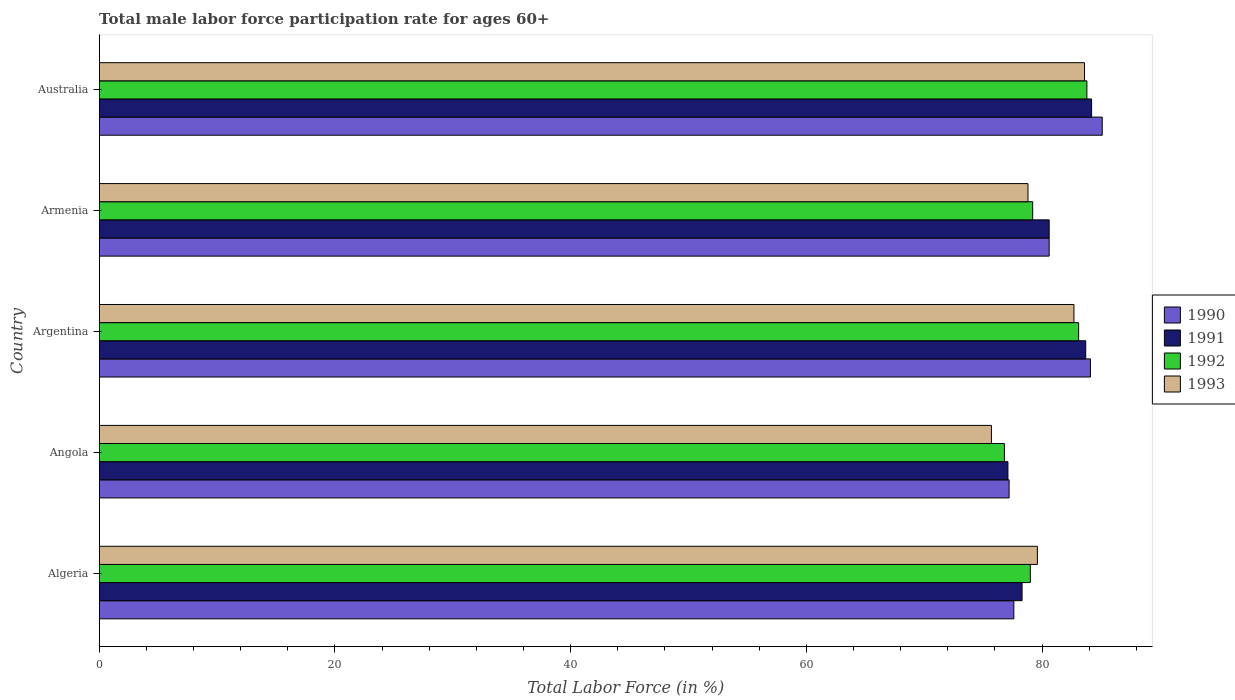How many different coloured bars are there?
Provide a short and direct response. 4. How many bars are there on the 2nd tick from the top?
Offer a terse response. 4. How many bars are there on the 4th tick from the bottom?
Keep it short and to the point. 4. What is the label of the 5th group of bars from the top?
Your answer should be very brief. Algeria. What is the male labor force participation rate in 1991 in Argentina?
Provide a short and direct response. 83.7. Across all countries, what is the maximum male labor force participation rate in 1991?
Keep it short and to the point. 84.2. Across all countries, what is the minimum male labor force participation rate in 1992?
Give a very brief answer. 76.8. In which country was the male labor force participation rate in 1991 maximum?
Provide a short and direct response. Australia. In which country was the male labor force participation rate in 1990 minimum?
Your answer should be compact. Angola. What is the total male labor force participation rate in 1992 in the graph?
Keep it short and to the point. 401.9. What is the difference between the male labor force participation rate in 1993 in Algeria and that in Armenia?
Offer a very short reply. 0.8. What is the average male labor force participation rate in 1990 per country?
Make the answer very short. 80.92. What is the difference between the male labor force participation rate in 1990 and male labor force participation rate in 1991 in Australia?
Offer a terse response. 0.9. In how many countries, is the male labor force participation rate in 1991 greater than 40 %?
Make the answer very short. 5. What is the ratio of the male labor force participation rate in 1990 in Algeria to that in Armenia?
Make the answer very short. 0.96. What is the difference between the highest and the second highest male labor force participation rate in 1992?
Your response must be concise. 0.7. What is the difference between the highest and the lowest male labor force participation rate in 1990?
Keep it short and to the point. 7.9. Is the sum of the male labor force participation rate in 1993 in Algeria and Australia greater than the maximum male labor force participation rate in 1991 across all countries?
Your answer should be compact. Yes. What does the 2nd bar from the top in Algeria represents?
Offer a terse response. 1992. What does the 2nd bar from the bottom in Australia represents?
Your answer should be compact. 1991. Is it the case that in every country, the sum of the male labor force participation rate in 1990 and male labor force participation rate in 1991 is greater than the male labor force participation rate in 1993?
Ensure brevity in your answer.  Yes. How many bars are there?
Your answer should be very brief. 20. Are all the bars in the graph horizontal?
Keep it short and to the point. Yes. How many countries are there in the graph?
Provide a short and direct response. 5. Are the values on the major ticks of X-axis written in scientific E-notation?
Provide a succinct answer. No. Does the graph contain any zero values?
Your answer should be compact. No. Where does the legend appear in the graph?
Your answer should be compact. Center right. How many legend labels are there?
Offer a very short reply. 4. How are the legend labels stacked?
Give a very brief answer. Vertical. What is the title of the graph?
Give a very brief answer. Total male labor force participation rate for ages 60+. Does "1978" appear as one of the legend labels in the graph?
Give a very brief answer. No. What is the label or title of the X-axis?
Offer a terse response. Total Labor Force (in %). What is the Total Labor Force (in %) in 1990 in Algeria?
Make the answer very short. 77.6. What is the Total Labor Force (in %) of 1991 in Algeria?
Ensure brevity in your answer.  78.3. What is the Total Labor Force (in %) in 1992 in Algeria?
Offer a terse response. 79. What is the Total Labor Force (in %) in 1993 in Algeria?
Offer a very short reply. 79.6. What is the Total Labor Force (in %) in 1990 in Angola?
Offer a very short reply. 77.2. What is the Total Labor Force (in %) of 1991 in Angola?
Provide a succinct answer. 77.1. What is the Total Labor Force (in %) in 1992 in Angola?
Ensure brevity in your answer.  76.8. What is the Total Labor Force (in %) in 1993 in Angola?
Your response must be concise. 75.7. What is the Total Labor Force (in %) in 1990 in Argentina?
Provide a succinct answer. 84.1. What is the Total Labor Force (in %) in 1991 in Argentina?
Your answer should be very brief. 83.7. What is the Total Labor Force (in %) of 1992 in Argentina?
Provide a succinct answer. 83.1. What is the Total Labor Force (in %) of 1993 in Argentina?
Offer a terse response. 82.7. What is the Total Labor Force (in %) of 1990 in Armenia?
Your answer should be very brief. 80.6. What is the Total Labor Force (in %) of 1991 in Armenia?
Offer a very short reply. 80.6. What is the Total Labor Force (in %) of 1992 in Armenia?
Your answer should be compact. 79.2. What is the Total Labor Force (in %) of 1993 in Armenia?
Ensure brevity in your answer.  78.8. What is the Total Labor Force (in %) of 1990 in Australia?
Ensure brevity in your answer.  85.1. What is the Total Labor Force (in %) in 1991 in Australia?
Offer a very short reply. 84.2. What is the Total Labor Force (in %) of 1992 in Australia?
Keep it short and to the point. 83.8. What is the Total Labor Force (in %) in 1993 in Australia?
Your answer should be very brief. 83.6. Across all countries, what is the maximum Total Labor Force (in %) of 1990?
Offer a terse response. 85.1. Across all countries, what is the maximum Total Labor Force (in %) of 1991?
Provide a short and direct response. 84.2. Across all countries, what is the maximum Total Labor Force (in %) in 1992?
Your response must be concise. 83.8. Across all countries, what is the maximum Total Labor Force (in %) of 1993?
Ensure brevity in your answer.  83.6. Across all countries, what is the minimum Total Labor Force (in %) in 1990?
Your answer should be compact. 77.2. Across all countries, what is the minimum Total Labor Force (in %) in 1991?
Provide a short and direct response. 77.1. Across all countries, what is the minimum Total Labor Force (in %) in 1992?
Offer a terse response. 76.8. Across all countries, what is the minimum Total Labor Force (in %) in 1993?
Ensure brevity in your answer.  75.7. What is the total Total Labor Force (in %) in 1990 in the graph?
Provide a succinct answer. 404.6. What is the total Total Labor Force (in %) of 1991 in the graph?
Provide a short and direct response. 403.9. What is the total Total Labor Force (in %) of 1992 in the graph?
Provide a succinct answer. 401.9. What is the total Total Labor Force (in %) of 1993 in the graph?
Your response must be concise. 400.4. What is the difference between the Total Labor Force (in %) of 1990 in Algeria and that in Angola?
Offer a terse response. 0.4. What is the difference between the Total Labor Force (in %) in 1993 in Algeria and that in Angola?
Provide a short and direct response. 3.9. What is the difference between the Total Labor Force (in %) of 1991 in Algeria and that in Argentina?
Your answer should be compact. -5.4. What is the difference between the Total Labor Force (in %) in 1993 in Algeria and that in Argentina?
Your answer should be very brief. -3.1. What is the difference between the Total Labor Force (in %) in 1990 in Algeria and that in Armenia?
Your answer should be very brief. -3. What is the difference between the Total Labor Force (in %) in 1991 in Algeria and that in Armenia?
Ensure brevity in your answer.  -2.3. What is the difference between the Total Labor Force (in %) in 1992 in Algeria and that in Armenia?
Keep it short and to the point. -0.2. What is the difference between the Total Labor Force (in %) in 1993 in Algeria and that in Armenia?
Provide a succinct answer. 0.8. What is the difference between the Total Labor Force (in %) in 1990 in Algeria and that in Australia?
Ensure brevity in your answer.  -7.5. What is the difference between the Total Labor Force (in %) of 1993 in Algeria and that in Australia?
Keep it short and to the point. -4. What is the difference between the Total Labor Force (in %) in 1991 in Angola and that in Argentina?
Make the answer very short. -6.6. What is the difference between the Total Labor Force (in %) of 1992 in Angola and that in Argentina?
Make the answer very short. -6.3. What is the difference between the Total Labor Force (in %) in 1990 in Angola and that in Armenia?
Ensure brevity in your answer.  -3.4. What is the difference between the Total Labor Force (in %) in 1991 in Angola and that in Armenia?
Your answer should be compact. -3.5. What is the difference between the Total Labor Force (in %) in 1992 in Angola and that in Armenia?
Keep it short and to the point. -2.4. What is the difference between the Total Labor Force (in %) in 1992 in Angola and that in Australia?
Offer a very short reply. -7. What is the difference between the Total Labor Force (in %) in 1992 in Argentina and that in Armenia?
Provide a succinct answer. 3.9. What is the difference between the Total Labor Force (in %) in 1993 in Argentina and that in Armenia?
Your response must be concise. 3.9. What is the difference between the Total Labor Force (in %) of 1993 in Argentina and that in Australia?
Give a very brief answer. -0.9. What is the difference between the Total Labor Force (in %) in 1990 in Algeria and the Total Labor Force (in %) in 1993 in Angola?
Keep it short and to the point. 1.9. What is the difference between the Total Labor Force (in %) of 1991 in Algeria and the Total Labor Force (in %) of 1992 in Angola?
Offer a terse response. 1.5. What is the difference between the Total Labor Force (in %) in 1990 in Algeria and the Total Labor Force (in %) in 1991 in Argentina?
Keep it short and to the point. -6.1. What is the difference between the Total Labor Force (in %) of 1990 in Algeria and the Total Labor Force (in %) of 1992 in Argentina?
Your answer should be compact. -5.5. What is the difference between the Total Labor Force (in %) in 1991 in Algeria and the Total Labor Force (in %) in 1992 in Argentina?
Provide a short and direct response. -4.8. What is the difference between the Total Labor Force (in %) in 1990 in Algeria and the Total Labor Force (in %) in 1991 in Armenia?
Give a very brief answer. -3. What is the difference between the Total Labor Force (in %) of 1990 in Algeria and the Total Labor Force (in %) of 1991 in Australia?
Give a very brief answer. -6.6. What is the difference between the Total Labor Force (in %) of 1990 in Algeria and the Total Labor Force (in %) of 1992 in Australia?
Ensure brevity in your answer.  -6.2. What is the difference between the Total Labor Force (in %) of 1991 in Algeria and the Total Labor Force (in %) of 1993 in Australia?
Your answer should be very brief. -5.3. What is the difference between the Total Labor Force (in %) in 1992 in Algeria and the Total Labor Force (in %) in 1993 in Australia?
Provide a succinct answer. -4.6. What is the difference between the Total Labor Force (in %) of 1990 in Angola and the Total Labor Force (in %) of 1991 in Argentina?
Keep it short and to the point. -6.5. What is the difference between the Total Labor Force (in %) of 1990 in Angola and the Total Labor Force (in %) of 1992 in Argentina?
Provide a short and direct response. -5.9. What is the difference between the Total Labor Force (in %) of 1991 in Angola and the Total Labor Force (in %) of 1992 in Argentina?
Ensure brevity in your answer.  -6. What is the difference between the Total Labor Force (in %) of 1992 in Angola and the Total Labor Force (in %) of 1993 in Argentina?
Give a very brief answer. -5.9. What is the difference between the Total Labor Force (in %) in 1990 in Angola and the Total Labor Force (in %) in 1991 in Armenia?
Offer a terse response. -3.4. What is the difference between the Total Labor Force (in %) in 1991 in Angola and the Total Labor Force (in %) in 1992 in Armenia?
Ensure brevity in your answer.  -2.1. What is the difference between the Total Labor Force (in %) of 1991 in Angola and the Total Labor Force (in %) of 1993 in Armenia?
Provide a succinct answer. -1.7. What is the difference between the Total Labor Force (in %) in 1990 in Argentina and the Total Labor Force (in %) in 1993 in Armenia?
Offer a terse response. 5.3. What is the difference between the Total Labor Force (in %) in 1991 in Argentina and the Total Labor Force (in %) in 1992 in Armenia?
Offer a terse response. 4.5. What is the difference between the Total Labor Force (in %) of 1990 in Argentina and the Total Labor Force (in %) of 1992 in Australia?
Offer a very short reply. 0.3. What is the difference between the Total Labor Force (in %) of 1990 in Argentina and the Total Labor Force (in %) of 1993 in Australia?
Provide a succinct answer. 0.5. What is the difference between the Total Labor Force (in %) in 1991 in Argentina and the Total Labor Force (in %) in 1993 in Australia?
Your answer should be very brief. 0.1. What is the difference between the Total Labor Force (in %) of 1992 in Argentina and the Total Labor Force (in %) of 1993 in Australia?
Keep it short and to the point. -0.5. What is the difference between the Total Labor Force (in %) in 1990 in Armenia and the Total Labor Force (in %) in 1991 in Australia?
Make the answer very short. -3.6. What is the difference between the Total Labor Force (in %) in 1990 in Armenia and the Total Labor Force (in %) in 1992 in Australia?
Your response must be concise. -3.2. What is the difference between the Total Labor Force (in %) in 1990 in Armenia and the Total Labor Force (in %) in 1993 in Australia?
Give a very brief answer. -3. What is the difference between the Total Labor Force (in %) of 1992 in Armenia and the Total Labor Force (in %) of 1993 in Australia?
Keep it short and to the point. -4.4. What is the average Total Labor Force (in %) of 1990 per country?
Make the answer very short. 80.92. What is the average Total Labor Force (in %) in 1991 per country?
Offer a very short reply. 80.78. What is the average Total Labor Force (in %) in 1992 per country?
Provide a short and direct response. 80.38. What is the average Total Labor Force (in %) of 1993 per country?
Your response must be concise. 80.08. What is the difference between the Total Labor Force (in %) of 1990 and Total Labor Force (in %) of 1991 in Algeria?
Make the answer very short. -0.7. What is the difference between the Total Labor Force (in %) in 1990 and Total Labor Force (in %) in 1992 in Algeria?
Provide a succinct answer. -1.4. What is the difference between the Total Labor Force (in %) of 1991 and Total Labor Force (in %) of 1992 in Algeria?
Your response must be concise. -0.7. What is the difference between the Total Labor Force (in %) of 1991 and Total Labor Force (in %) of 1993 in Algeria?
Your answer should be compact. -1.3. What is the difference between the Total Labor Force (in %) in 1992 and Total Labor Force (in %) in 1993 in Algeria?
Give a very brief answer. -0.6. What is the difference between the Total Labor Force (in %) of 1990 and Total Labor Force (in %) of 1992 in Angola?
Your response must be concise. 0.4. What is the difference between the Total Labor Force (in %) of 1991 and Total Labor Force (in %) of 1993 in Angola?
Your answer should be compact. 1.4. What is the difference between the Total Labor Force (in %) in 1990 and Total Labor Force (in %) in 1991 in Argentina?
Keep it short and to the point. 0.4. What is the difference between the Total Labor Force (in %) of 1990 and Total Labor Force (in %) of 1993 in Argentina?
Your answer should be compact. 1.4. What is the difference between the Total Labor Force (in %) in 1990 and Total Labor Force (in %) in 1991 in Armenia?
Keep it short and to the point. 0. What is the difference between the Total Labor Force (in %) in 1991 and Total Labor Force (in %) in 1992 in Armenia?
Give a very brief answer. 1.4. What is the difference between the Total Labor Force (in %) of 1992 and Total Labor Force (in %) of 1993 in Armenia?
Offer a terse response. 0.4. What is the difference between the Total Labor Force (in %) in 1990 and Total Labor Force (in %) in 1993 in Australia?
Your answer should be compact. 1.5. What is the ratio of the Total Labor Force (in %) in 1990 in Algeria to that in Angola?
Give a very brief answer. 1.01. What is the ratio of the Total Labor Force (in %) of 1991 in Algeria to that in Angola?
Keep it short and to the point. 1.02. What is the ratio of the Total Labor Force (in %) of 1992 in Algeria to that in Angola?
Make the answer very short. 1.03. What is the ratio of the Total Labor Force (in %) in 1993 in Algeria to that in Angola?
Provide a succinct answer. 1.05. What is the ratio of the Total Labor Force (in %) of 1990 in Algeria to that in Argentina?
Your response must be concise. 0.92. What is the ratio of the Total Labor Force (in %) of 1991 in Algeria to that in Argentina?
Ensure brevity in your answer.  0.94. What is the ratio of the Total Labor Force (in %) in 1992 in Algeria to that in Argentina?
Ensure brevity in your answer.  0.95. What is the ratio of the Total Labor Force (in %) of 1993 in Algeria to that in Argentina?
Your response must be concise. 0.96. What is the ratio of the Total Labor Force (in %) in 1990 in Algeria to that in Armenia?
Keep it short and to the point. 0.96. What is the ratio of the Total Labor Force (in %) of 1991 in Algeria to that in Armenia?
Ensure brevity in your answer.  0.97. What is the ratio of the Total Labor Force (in %) in 1992 in Algeria to that in Armenia?
Your answer should be very brief. 1. What is the ratio of the Total Labor Force (in %) in 1993 in Algeria to that in Armenia?
Your answer should be compact. 1.01. What is the ratio of the Total Labor Force (in %) in 1990 in Algeria to that in Australia?
Offer a terse response. 0.91. What is the ratio of the Total Labor Force (in %) of 1991 in Algeria to that in Australia?
Offer a very short reply. 0.93. What is the ratio of the Total Labor Force (in %) of 1992 in Algeria to that in Australia?
Your answer should be compact. 0.94. What is the ratio of the Total Labor Force (in %) of 1993 in Algeria to that in Australia?
Keep it short and to the point. 0.95. What is the ratio of the Total Labor Force (in %) of 1990 in Angola to that in Argentina?
Provide a short and direct response. 0.92. What is the ratio of the Total Labor Force (in %) of 1991 in Angola to that in Argentina?
Provide a short and direct response. 0.92. What is the ratio of the Total Labor Force (in %) of 1992 in Angola to that in Argentina?
Provide a short and direct response. 0.92. What is the ratio of the Total Labor Force (in %) of 1993 in Angola to that in Argentina?
Your answer should be compact. 0.92. What is the ratio of the Total Labor Force (in %) in 1990 in Angola to that in Armenia?
Your answer should be very brief. 0.96. What is the ratio of the Total Labor Force (in %) in 1991 in Angola to that in Armenia?
Provide a short and direct response. 0.96. What is the ratio of the Total Labor Force (in %) of 1992 in Angola to that in Armenia?
Provide a short and direct response. 0.97. What is the ratio of the Total Labor Force (in %) of 1993 in Angola to that in Armenia?
Your response must be concise. 0.96. What is the ratio of the Total Labor Force (in %) of 1990 in Angola to that in Australia?
Your answer should be compact. 0.91. What is the ratio of the Total Labor Force (in %) in 1991 in Angola to that in Australia?
Ensure brevity in your answer.  0.92. What is the ratio of the Total Labor Force (in %) in 1992 in Angola to that in Australia?
Your response must be concise. 0.92. What is the ratio of the Total Labor Force (in %) of 1993 in Angola to that in Australia?
Keep it short and to the point. 0.91. What is the ratio of the Total Labor Force (in %) of 1990 in Argentina to that in Armenia?
Give a very brief answer. 1.04. What is the ratio of the Total Labor Force (in %) of 1992 in Argentina to that in Armenia?
Offer a terse response. 1.05. What is the ratio of the Total Labor Force (in %) of 1993 in Argentina to that in Armenia?
Your response must be concise. 1.05. What is the ratio of the Total Labor Force (in %) of 1991 in Argentina to that in Australia?
Offer a very short reply. 0.99. What is the ratio of the Total Labor Force (in %) of 1992 in Argentina to that in Australia?
Offer a terse response. 0.99. What is the ratio of the Total Labor Force (in %) in 1993 in Argentina to that in Australia?
Ensure brevity in your answer.  0.99. What is the ratio of the Total Labor Force (in %) in 1990 in Armenia to that in Australia?
Make the answer very short. 0.95. What is the ratio of the Total Labor Force (in %) of 1991 in Armenia to that in Australia?
Provide a short and direct response. 0.96. What is the ratio of the Total Labor Force (in %) in 1992 in Armenia to that in Australia?
Provide a short and direct response. 0.95. What is the ratio of the Total Labor Force (in %) in 1993 in Armenia to that in Australia?
Give a very brief answer. 0.94. What is the difference between the highest and the lowest Total Labor Force (in %) of 1990?
Offer a very short reply. 7.9. What is the difference between the highest and the lowest Total Labor Force (in %) of 1991?
Provide a short and direct response. 7.1. What is the difference between the highest and the lowest Total Labor Force (in %) of 1993?
Your answer should be compact. 7.9. 